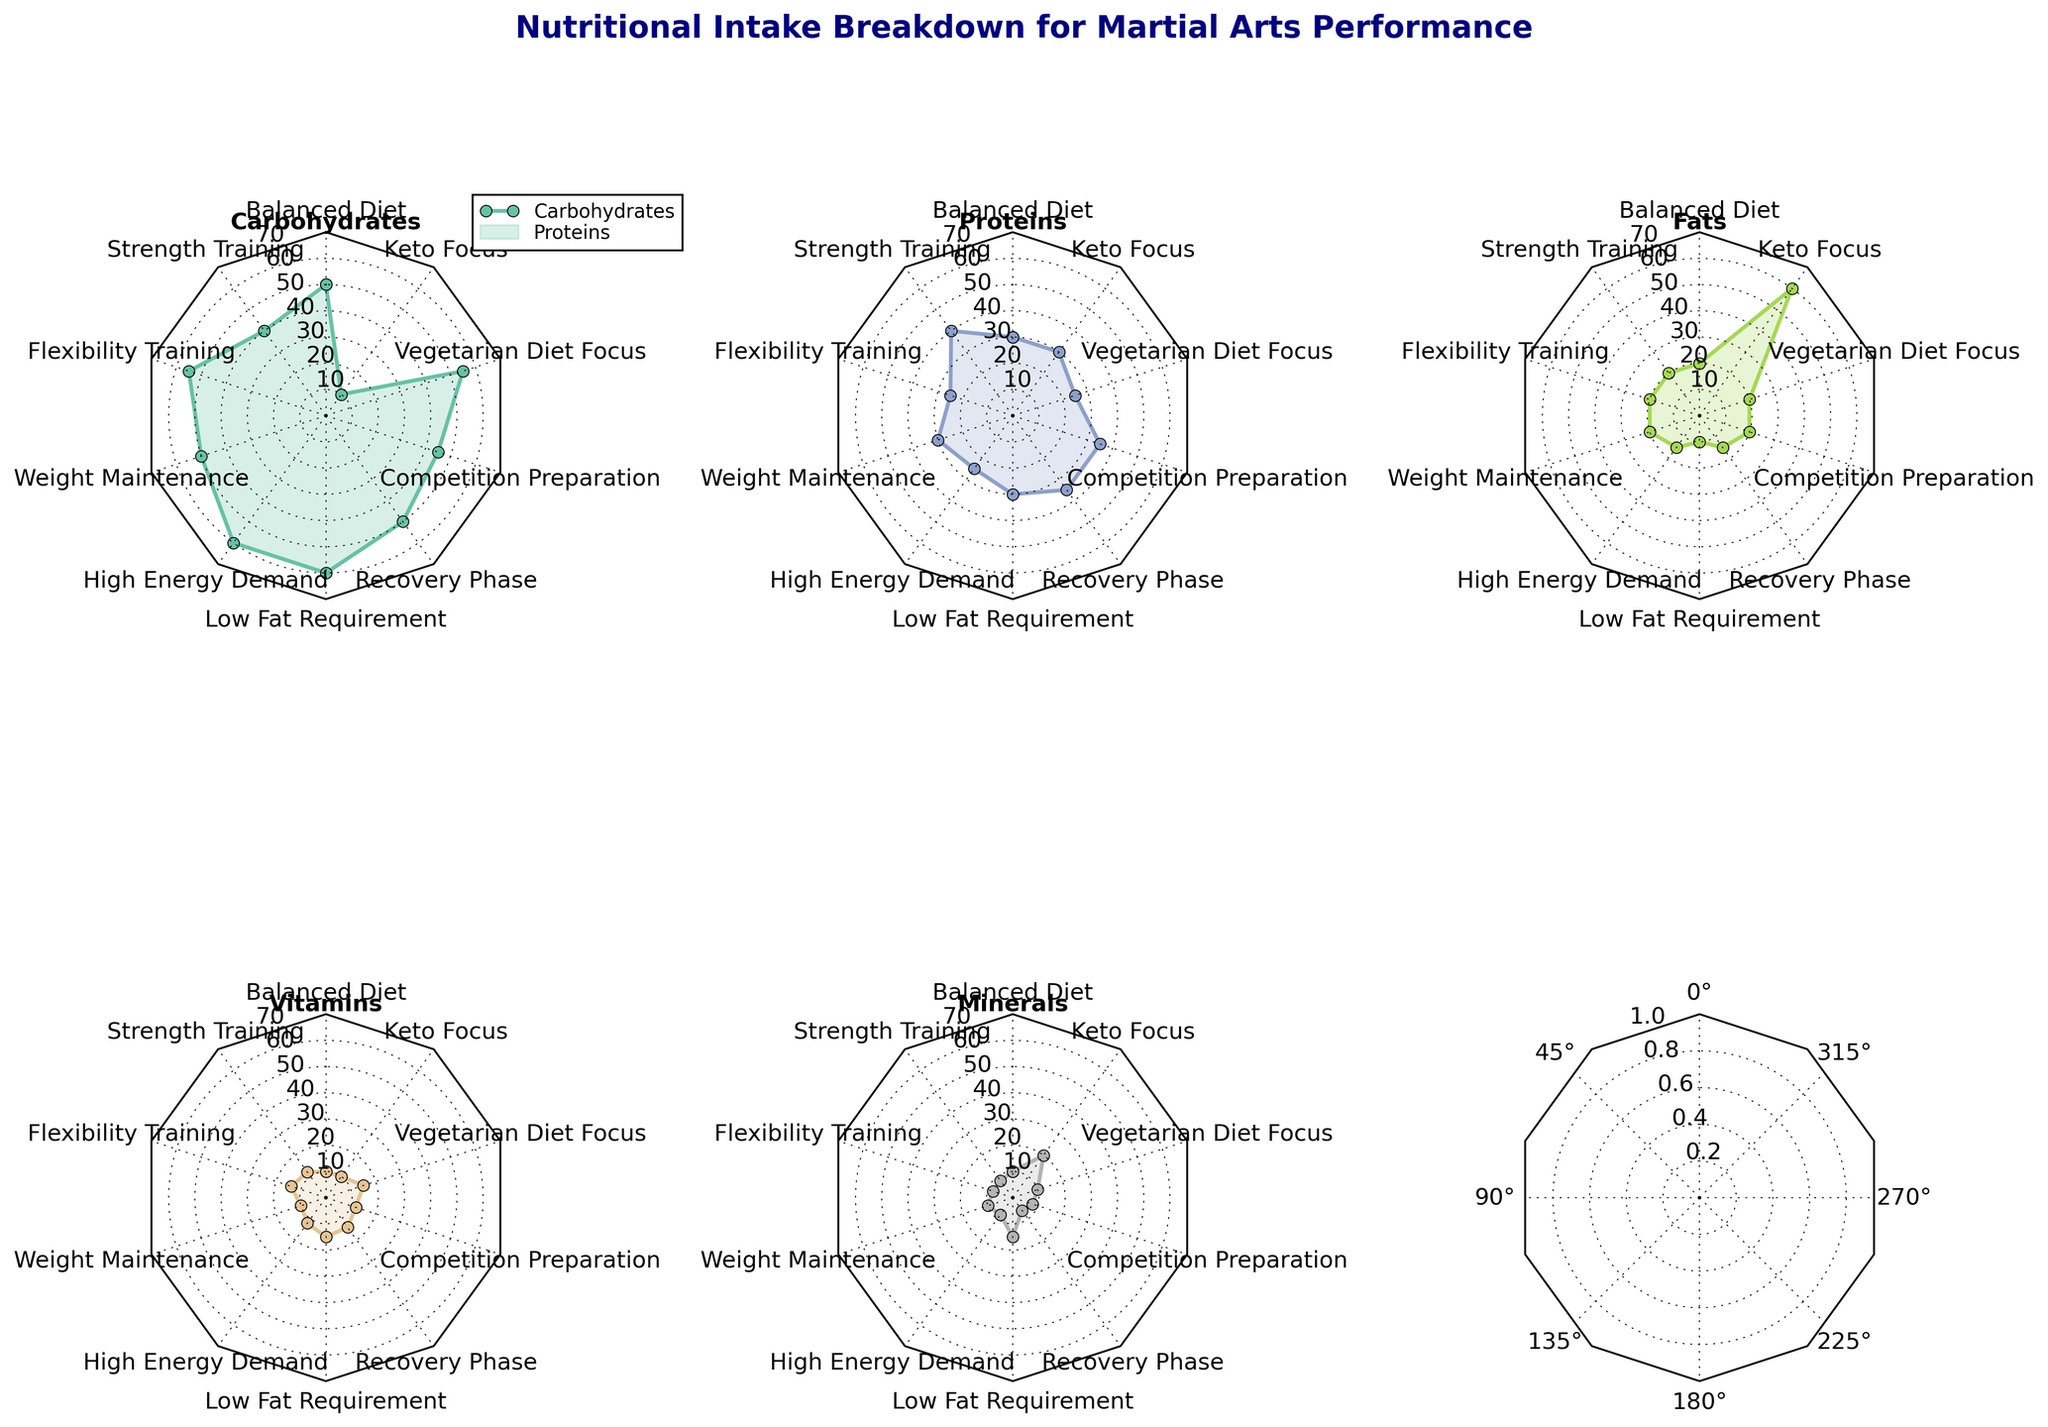Which diet has the highest percentage of carbohydrates? To determine which diet has the highest percentage of carbohydrates, look for the axis labeled "Carbohydrates" and find the highest value among all the plots. The "High Energy Demand" diet has the highest carbohydrate value at 60%.
Answer: High Energy Demand How does the protein intake of the "Recovery Phase" compare to "Weight Maintenance"? First, locate the protein intake values for both diets on the radar chart. "Recovery Phase" shows a protein intake of 35%, whereas "Weight Maintenance" has 30%. Therefore, "Recovery Phase" has a higher protein intake by 5%.
Answer: Recovery Phase is higher by 5% Which diet focuses the least on fat intake? Look at the axis labeled "Fats" and identify the diet with the lowest value. The "Low Fat Requirement" and "Keto Focus" diets have the lowest fat intake at 10%.
Answer: Low Fat Requirement and Keto Focus What is the sum of the vitamin intake for "Flexibility Training" and "Competition Preparation"? Find the vitamin intake values for "Flexibility Training" and "Competition Preparation" diets. These values are 14% and 12%, respectively. Adding them yields 14% + 12% = 26%.
Answer: 26% Which diet has the maximum mineral intake? To find the diet with the highest percentage of minerals, look at the axis labeled "Minerals" and identify the plot with the highest value. The "Low Fat Requirement" diet has the highest mineral value at 15%.
Answer: Low Fat Requirement What is the average carbohydrate intake across all diets? Sum the carbohydrate intake values for all the diets and divide by the number of diets. (50 + 40 + 55 + 50 + 60 + 60 + 50 + 45 + 55 + 10) / 10 = 475 / 10 = 47.5%.
Answer: 47.5% How many diets have a protein intake greater than or equal to 30%? Count the number of diets with protein intake values of 30% or higher. "Balanced Diet", "Strength Training", "Weight Maintenance", "Low Fat Requirement", "Recovery Phase", and "Competition Preparation" each have protein intake values of at least 30%. This gives us a total of 6 diets.
Answer: 6 Which diet has the highest balance of macronutrients (carbohydrates, proteins, and fats)? To assess balance, find the diet with the most even distribution between carbohydrates, proteins, and fats. The "Balanced Diet" has values of 50%, 30%, and 20%, appearing the most even amongst the macronutrients compared to others.
Answer: Balanced Diet What is the difference in fat intake between "High Energy Demand" and "Keto Focus"? First, identify the fat intake values for both diets from the radar chart. "High Energy Demand" has 15%, and "Keto Focus" has 60%. The difference is 60% - 15% = 45%.
Answer: 45% Which diet is closest to having equal proportions of all macronutrients and micronutrients? Find the diet with values closest to 20% for all categories. The "Recovery Phase" diet, with values of 50% carbohydrates, 35% proteins, 15% fats, 14% vitamins, and 6% minerals, shows the closest to equal proportions.
Answer: Recovery Phase 